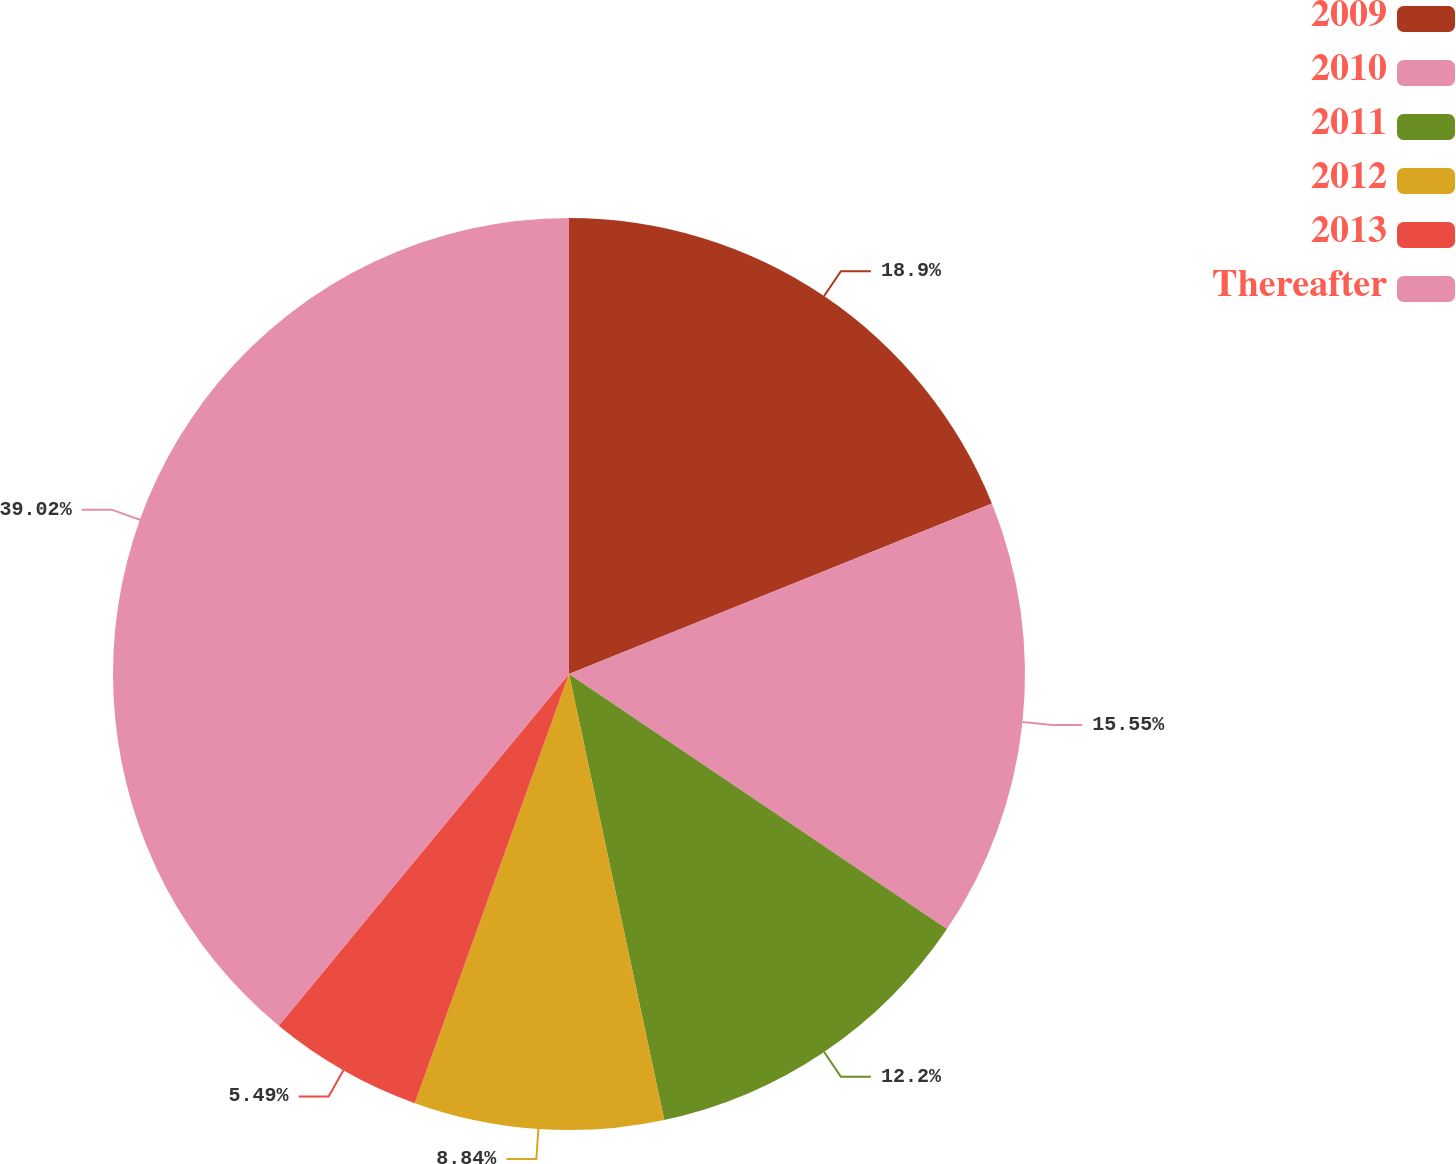<chart> <loc_0><loc_0><loc_500><loc_500><pie_chart><fcel>2009<fcel>2010<fcel>2011<fcel>2012<fcel>2013<fcel>Thereafter<nl><fcel>18.9%<fcel>15.55%<fcel>12.2%<fcel>8.84%<fcel>5.49%<fcel>39.02%<nl></chart> 